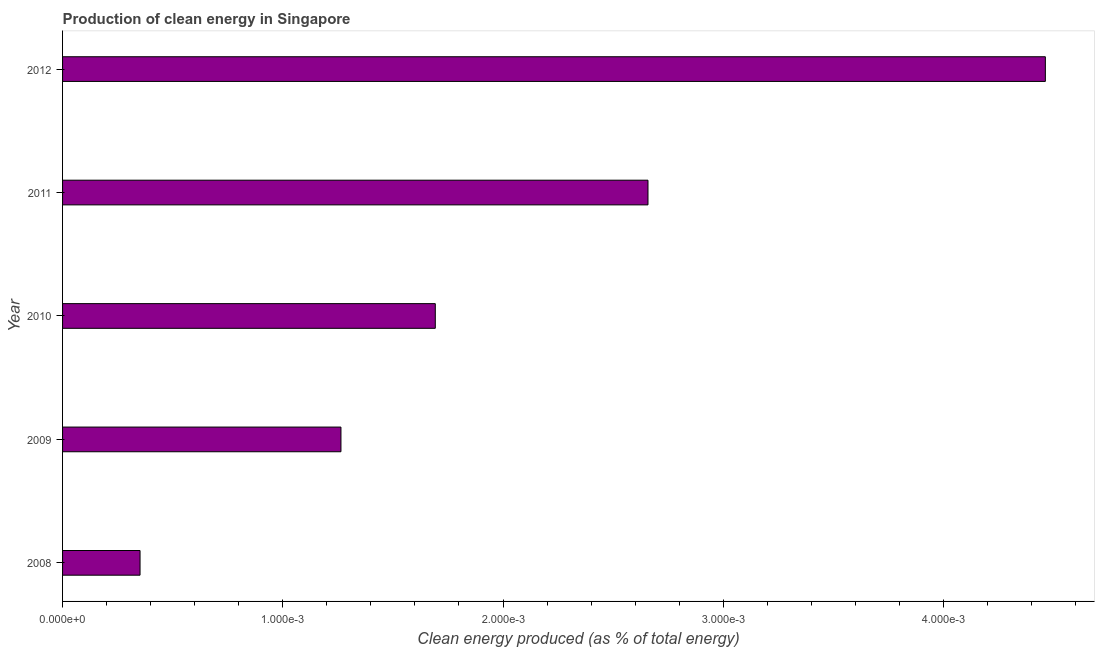Does the graph contain any zero values?
Offer a terse response. No. Does the graph contain grids?
Offer a very short reply. No. What is the title of the graph?
Offer a very short reply. Production of clean energy in Singapore. What is the label or title of the X-axis?
Keep it short and to the point. Clean energy produced (as % of total energy). What is the label or title of the Y-axis?
Your answer should be compact. Year. What is the production of clean energy in 2011?
Make the answer very short. 0. Across all years, what is the maximum production of clean energy?
Make the answer very short. 0. Across all years, what is the minimum production of clean energy?
Keep it short and to the point. 0. What is the sum of the production of clean energy?
Make the answer very short. 0.01. What is the difference between the production of clean energy in 2009 and 2012?
Your answer should be compact. -0. What is the average production of clean energy per year?
Give a very brief answer. 0. What is the median production of clean energy?
Your answer should be very brief. 0. In how many years, is the production of clean energy greater than 0.0036 %?
Provide a short and direct response. 1. What is the ratio of the production of clean energy in 2008 to that in 2012?
Ensure brevity in your answer.  0.08. Is the production of clean energy in 2008 less than that in 2011?
Give a very brief answer. Yes. Is the difference between the production of clean energy in 2008 and 2009 greater than the difference between any two years?
Your response must be concise. No. What is the difference between the highest and the second highest production of clean energy?
Your answer should be compact. 0. Is the sum of the production of clean energy in 2010 and 2012 greater than the maximum production of clean energy across all years?
Offer a very short reply. Yes. In how many years, is the production of clean energy greater than the average production of clean energy taken over all years?
Offer a terse response. 2. Are all the bars in the graph horizontal?
Your answer should be very brief. Yes. How many years are there in the graph?
Your answer should be compact. 5. What is the Clean energy produced (as % of total energy) in 2008?
Ensure brevity in your answer.  0. What is the Clean energy produced (as % of total energy) in 2009?
Ensure brevity in your answer.  0. What is the Clean energy produced (as % of total energy) in 2010?
Your response must be concise. 0. What is the Clean energy produced (as % of total energy) of 2011?
Your response must be concise. 0. What is the Clean energy produced (as % of total energy) of 2012?
Offer a terse response. 0. What is the difference between the Clean energy produced (as % of total energy) in 2008 and 2009?
Provide a succinct answer. -0. What is the difference between the Clean energy produced (as % of total energy) in 2008 and 2010?
Make the answer very short. -0. What is the difference between the Clean energy produced (as % of total energy) in 2008 and 2011?
Your response must be concise. -0. What is the difference between the Clean energy produced (as % of total energy) in 2008 and 2012?
Keep it short and to the point. -0. What is the difference between the Clean energy produced (as % of total energy) in 2009 and 2010?
Offer a terse response. -0. What is the difference between the Clean energy produced (as % of total energy) in 2009 and 2011?
Your response must be concise. -0. What is the difference between the Clean energy produced (as % of total energy) in 2009 and 2012?
Your response must be concise. -0. What is the difference between the Clean energy produced (as % of total energy) in 2010 and 2011?
Provide a short and direct response. -0. What is the difference between the Clean energy produced (as % of total energy) in 2010 and 2012?
Your answer should be compact. -0. What is the difference between the Clean energy produced (as % of total energy) in 2011 and 2012?
Your response must be concise. -0. What is the ratio of the Clean energy produced (as % of total energy) in 2008 to that in 2009?
Keep it short and to the point. 0.28. What is the ratio of the Clean energy produced (as % of total energy) in 2008 to that in 2010?
Offer a very short reply. 0.21. What is the ratio of the Clean energy produced (as % of total energy) in 2008 to that in 2011?
Make the answer very short. 0.13. What is the ratio of the Clean energy produced (as % of total energy) in 2008 to that in 2012?
Your answer should be very brief. 0.08. What is the ratio of the Clean energy produced (as % of total energy) in 2009 to that in 2010?
Your answer should be compact. 0.75. What is the ratio of the Clean energy produced (as % of total energy) in 2009 to that in 2011?
Make the answer very short. 0.48. What is the ratio of the Clean energy produced (as % of total energy) in 2009 to that in 2012?
Your response must be concise. 0.28. What is the ratio of the Clean energy produced (as % of total energy) in 2010 to that in 2011?
Provide a succinct answer. 0.64. What is the ratio of the Clean energy produced (as % of total energy) in 2010 to that in 2012?
Make the answer very short. 0.38. What is the ratio of the Clean energy produced (as % of total energy) in 2011 to that in 2012?
Your answer should be very brief. 0.6. 